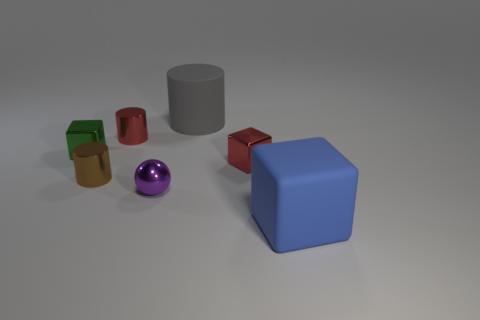What shape is the tiny purple object?
Offer a very short reply. Sphere. What number of red metallic things are on the right side of the big gray thing that is behind the large thing that is in front of the purple object?
Your response must be concise. 1. There is another small metallic object that is the same shape as the small green object; what is its color?
Give a very brief answer. Red. There is a red shiny object in front of the small cylinder that is right of the brown metallic cylinder to the left of the big gray thing; what is its shape?
Your answer should be compact. Cube. What size is the cube that is on the left side of the blue object and to the right of the small brown shiny thing?
Your answer should be very brief. Small. Is the number of green objects less than the number of blue metallic balls?
Offer a terse response. No. What is the size of the metallic cylinder right of the small brown thing?
Provide a succinct answer. Small. What shape is the tiny metallic object that is behind the tiny brown cylinder and on the left side of the tiny red cylinder?
Offer a very short reply. Cube. There is a red metal object that is the same shape as the tiny brown shiny thing; what is its size?
Provide a succinct answer. Small. How many other things have the same material as the small purple object?
Ensure brevity in your answer.  4. 